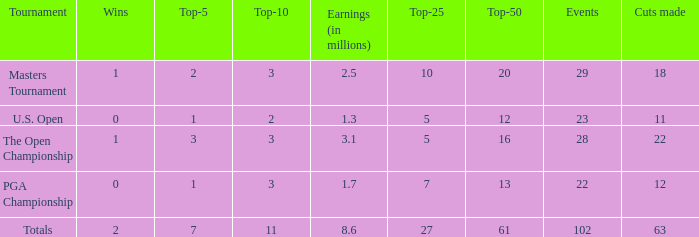Give me the full table as a dictionary. {'header': ['Tournament', 'Wins', 'Top-5', 'Top-10', 'Earnings (in millions)', 'Top-25', 'Top-50', 'Events', 'Cuts made'], 'rows': [['Masters Tournament', '1', '2', '3', '2.5', '10', '20', '29', '18'], ['U.S. Open', '0', '1', '2', '1.3', '5', '12', '23', '11'], ['The Open Championship', '1', '3', '3', '3.1', '5', '16', '28', '22'], ['PGA Championship', '0', '1', '3', '1.7', '7', '13', '22', '12'], ['Totals', '2', '7', '11', '8.6', '27', '61', '102', '63']]} How many top 10s when he had under 1 top 5s? None. 